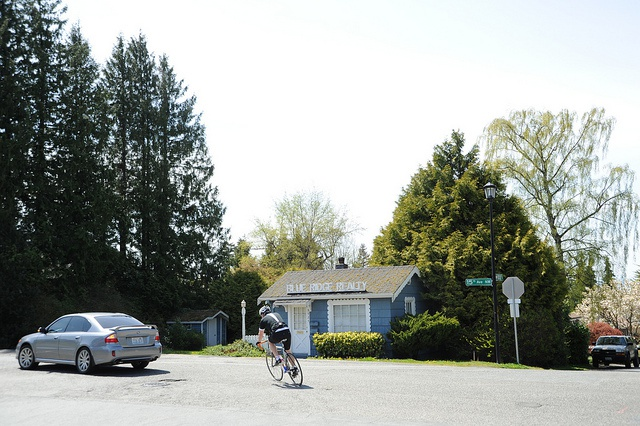Describe the objects in this image and their specific colors. I can see car in darkblue, gray, black, and darkgray tones, car in darkblue, black, gray, blue, and darkgray tones, people in darkblue, black, gray, darkgray, and lightgray tones, bicycle in darkblue, lightgray, gray, darkgray, and black tones, and stop sign in darkblue and gray tones in this image. 